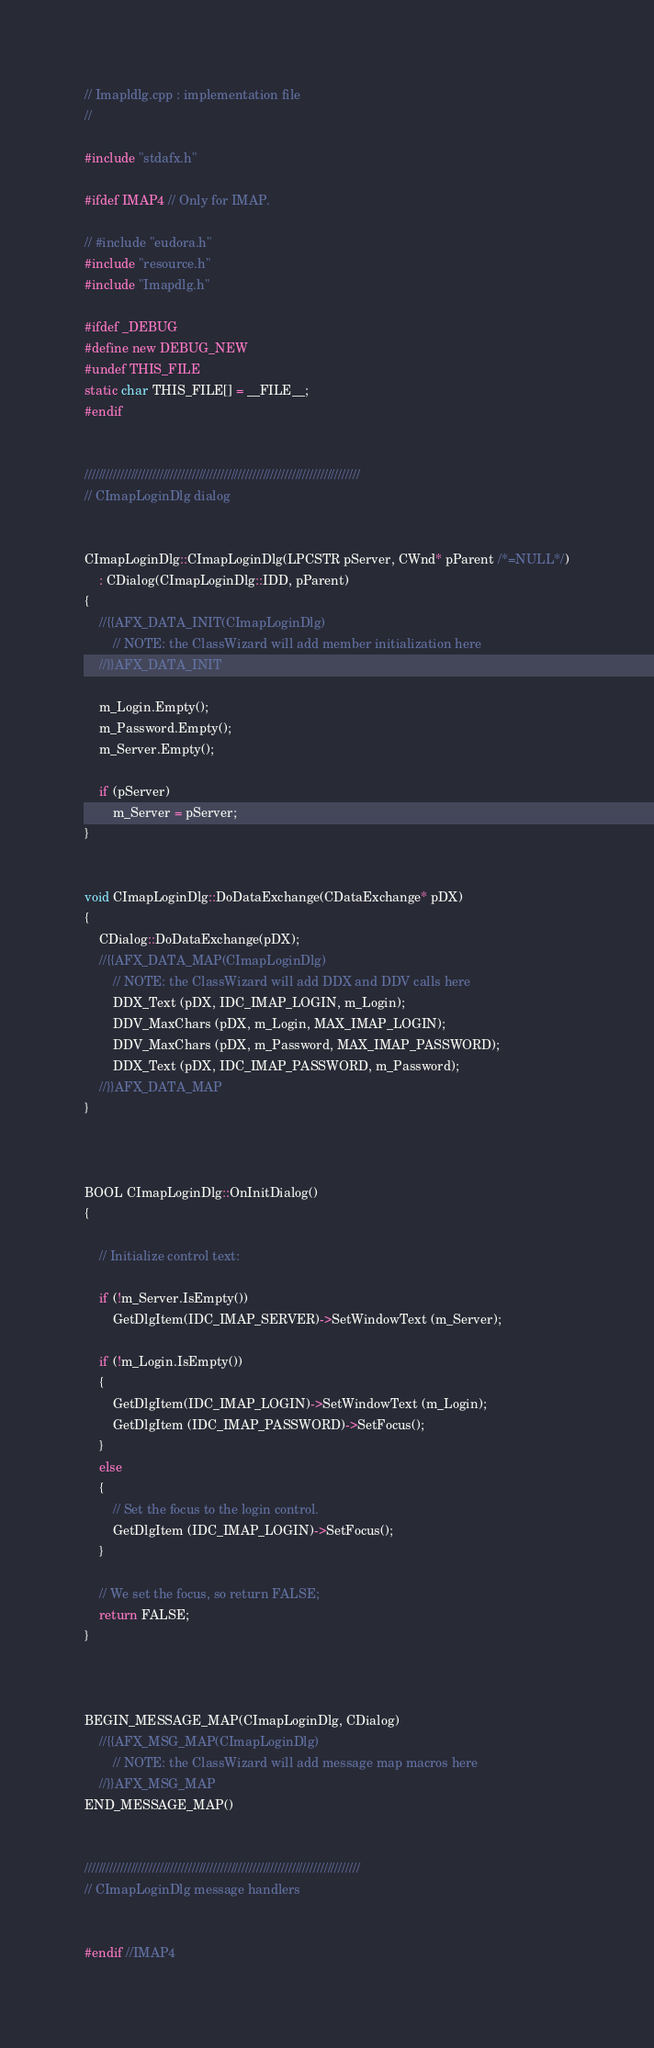<code> <loc_0><loc_0><loc_500><loc_500><_C++_>// Imapldlg.cpp : implementation file
//

#include "stdafx.h"

#ifdef IMAP4 // Only for IMAP.

// #include "eudora.h"
#include "resource.h"
#include "Imapdlg.h"

#ifdef _DEBUG
#define new DEBUG_NEW
#undef THIS_FILE
static char THIS_FILE[] = __FILE__;
#endif


/////////////////////////////////////////////////////////////////////////////
// CImapLoginDlg dialog


CImapLoginDlg::CImapLoginDlg(LPCSTR pServer, CWnd* pParent /*=NULL*/)
	: CDialog(CImapLoginDlg::IDD, pParent)
{
	//{{AFX_DATA_INIT(CImapLoginDlg)
		// NOTE: the ClassWizard will add member initialization here
	//}}AFX_DATA_INIT

	m_Login.Empty();
	m_Password.Empty();
	m_Server.Empty();

	if (pServer)
		m_Server = pServer;
}


void CImapLoginDlg::DoDataExchange(CDataExchange* pDX)
{
	CDialog::DoDataExchange(pDX);
	//{{AFX_DATA_MAP(CImapLoginDlg)
		// NOTE: the ClassWizard will add DDX and DDV calls here
		DDX_Text (pDX, IDC_IMAP_LOGIN, m_Login);
		DDV_MaxChars (pDX, m_Login, MAX_IMAP_LOGIN);
		DDV_MaxChars (pDX, m_Password, MAX_IMAP_PASSWORD);
		DDX_Text (pDX, IDC_IMAP_PASSWORD, m_Password);
	//}}AFX_DATA_MAP
}



BOOL CImapLoginDlg::OnInitDialog()
{

	// Initialize control text:

	if (!m_Server.IsEmpty())
		GetDlgItem(IDC_IMAP_SERVER)->SetWindowText (m_Server);

	if (!m_Login.IsEmpty())
	{
		GetDlgItem(IDC_IMAP_LOGIN)->SetWindowText (m_Login);
		GetDlgItem (IDC_IMAP_PASSWORD)->SetFocus();
	}
	else
	{
		// Set the focus to the login control.
		GetDlgItem (IDC_IMAP_LOGIN)->SetFocus();
	}

	// We set the focus, so return FALSE;
	return FALSE;
}



BEGIN_MESSAGE_MAP(CImapLoginDlg, CDialog)
	//{{AFX_MSG_MAP(CImapLoginDlg)
		// NOTE: the ClassWizard will add message map macros here
	//}}AFX_MSG_MAP
END_MESSAGE_MAP()


/////////////////////////////////////////////////////////////////////////////
// CImapLoginDlg message handlers


#endif //IMAP4


</code> 